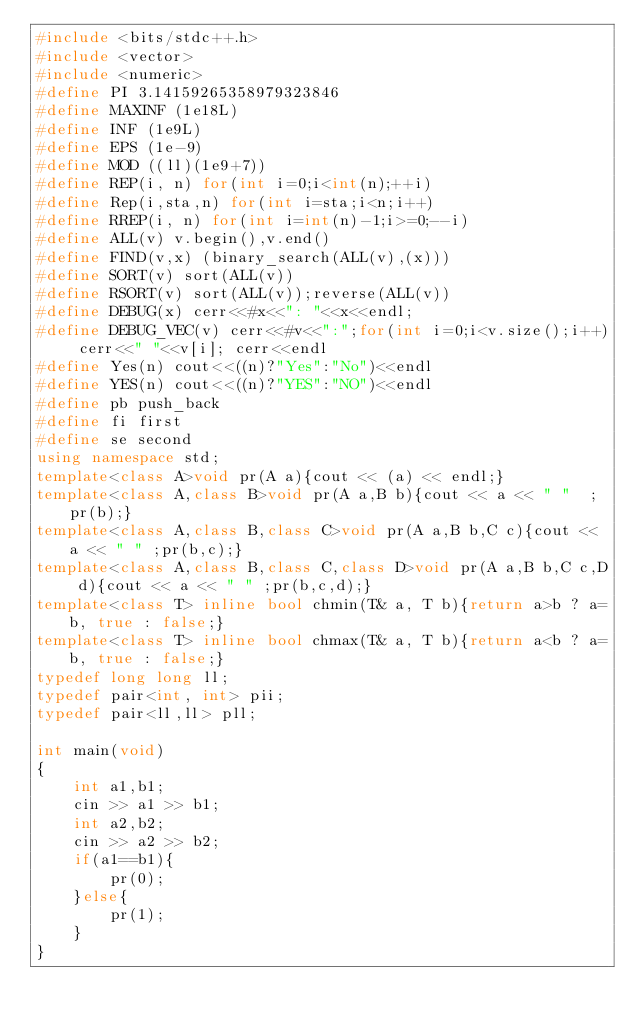<code> <loc_0><loc_0><loc_500><loc_500><_C++_>#include <bits/stdc++.h>
#include <vector>
#include <numeric>
#define PI 3.14159265358979323846
#define MAXINF (1e18L)
#define INF (1e9L)
#define EPS (1e-9)
#define MOD ((ll)(1e9+7))
#define REP(i, n) for(int i=0;i<int(n);++i)
#define Rep(i,sta,n) for(int i=sta;i<n;i++)
#define RREP(i, n) for(int i=int(n)-1;i>=0;--i)
#define ALL(v) v.begin(),v.end()
#define FIND(v,x) (binary_search(ALL(v),(x)))
#define SORT(v) sort(ALL(v))
#define RSORT(v) sort(ALL(v));reverse(ALL(v))
#define DEBUG(x) cerr<<#x<<": "<<x<<endl;
#define DEBUG_VEC(v) cerr<<#v<<":";for(int i=0;i<v.size();i++) cerr<<" "<<v[i]; cerr<<endl
#define Yes(n) cout<<((n)?"Yes":"No")<<endl
#define YES(n) cout<<((n)?"YES":"NO")<<endl
#define pb push_back
#define fi first
#define se second
using namespace std;
template<class A>void pr(A a){cout << (a) << endl;}
template<class A,class B>void pr(A a,B b){cout << a << " "  ;pr(b);}
template<class A,class B,class C>void pr(A a,B b,C c){cout << a << " " ;pr(b,c);}
template<class A,class B,class C,class D>void pr(A a,B b,C c,D d){cout << a << " " ;pr(b,c,d);}
template<class T> inline bool chmin(T& a, T b){return a>b ? a=b, true : false;}
template<class T> inline bool chmax(T& a, T b){return a<b ? a=b, true : false;}
typedef long long ll;
typedef pair<int, int> pii;
typedef pair<ll,ll> pll;

int main(void)
{
    int a1,b1;
    cin >> a1 >> b1;
    int a2,b2;
    cin >> a2 >> b2;
    if(a1==b1){
        pr(0);
    }else{
        pr(1);
    }
}</code> 